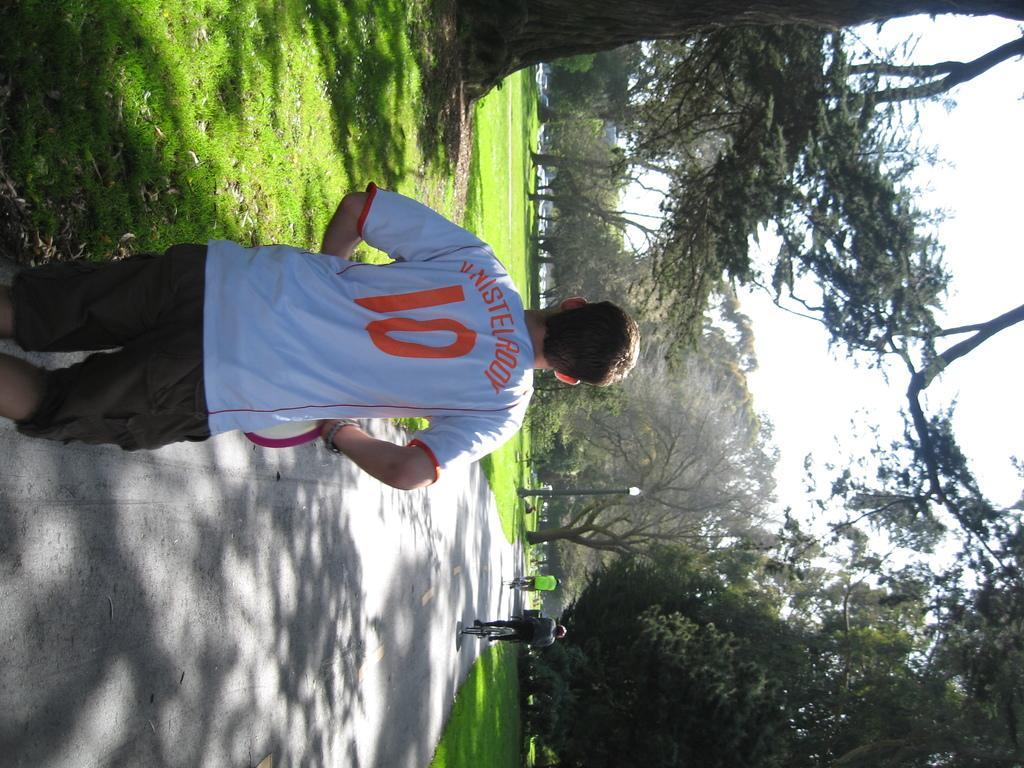In one or two sentences, can you explain what this image depicts? In the image there is a person in white t-shirt and short jogging on the road and in front there are two persons cycling, this is an inverted image, on either side of the road there is grassland with trees all over it and above its sky. 